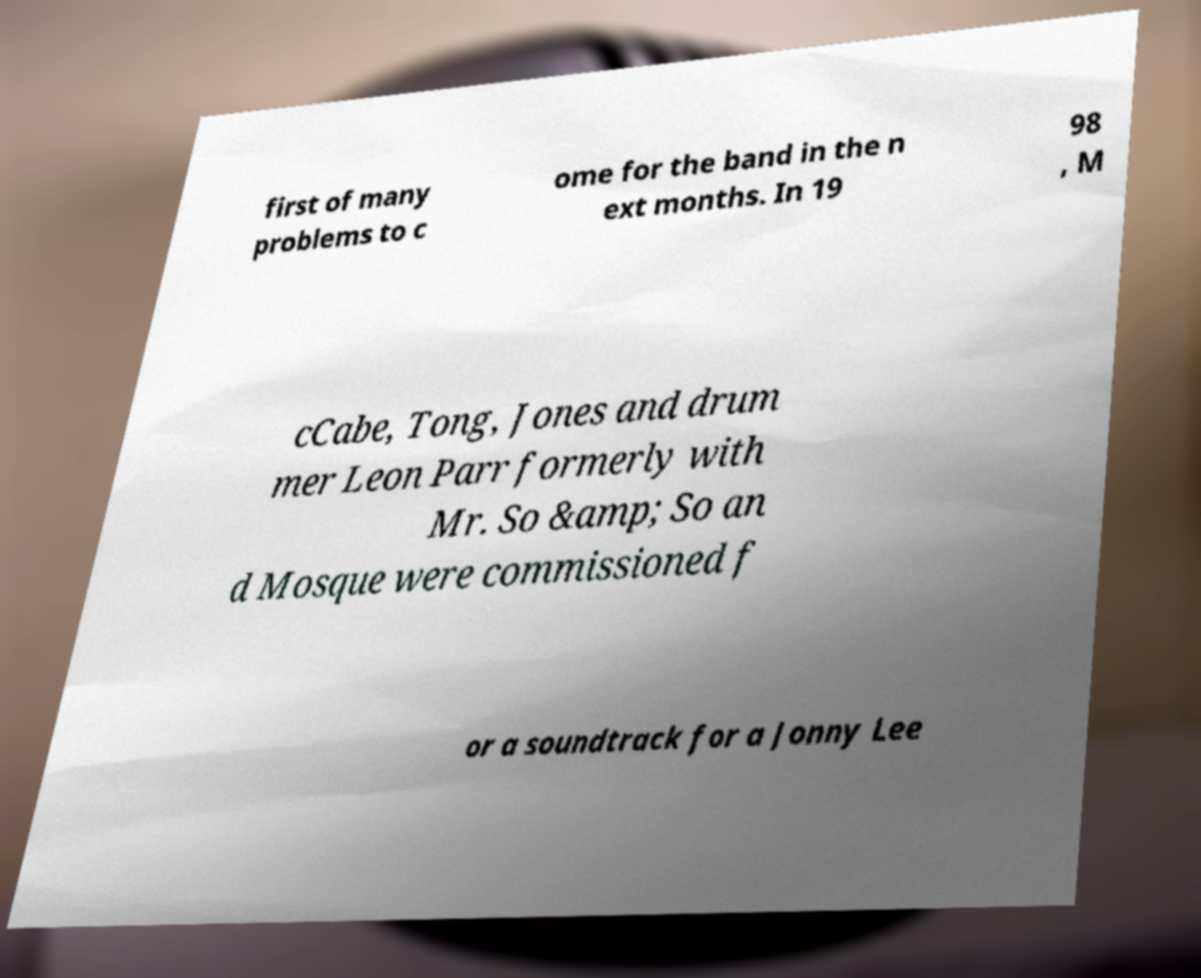Please identify and transcribe the text found in this image. first of many problems to c ome for the band in the n ext months. In 19 98 , M cCabe, Tong, Jones and drum mer Leon Parr formerly with Mr. So &amp; So an d Mosque were commissioned f or a soundtrack for a Jonny Lee 